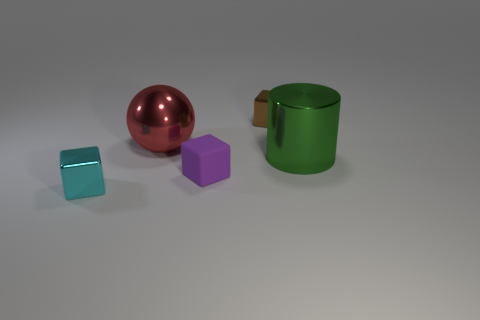Subtract all purple blocks. How many blocks are left? 2 Add 1 tiny cyan metal objects. How many objects exist? 6 Subtract all spheres. How many objects are left? 4 Subtract all gray cubes. Subtract all yellow balls. How many cubes are left? 3 Add 1 brown cubes. How many brown cubes are left? 2 Add 1 purple cubes. How many purple cubes exist? 2 Subtract 0 purple spheres. How many objects are left? 5 Subtract all blue spheres. Subtract all tiny brown metal objects. How many objects are left? 4 